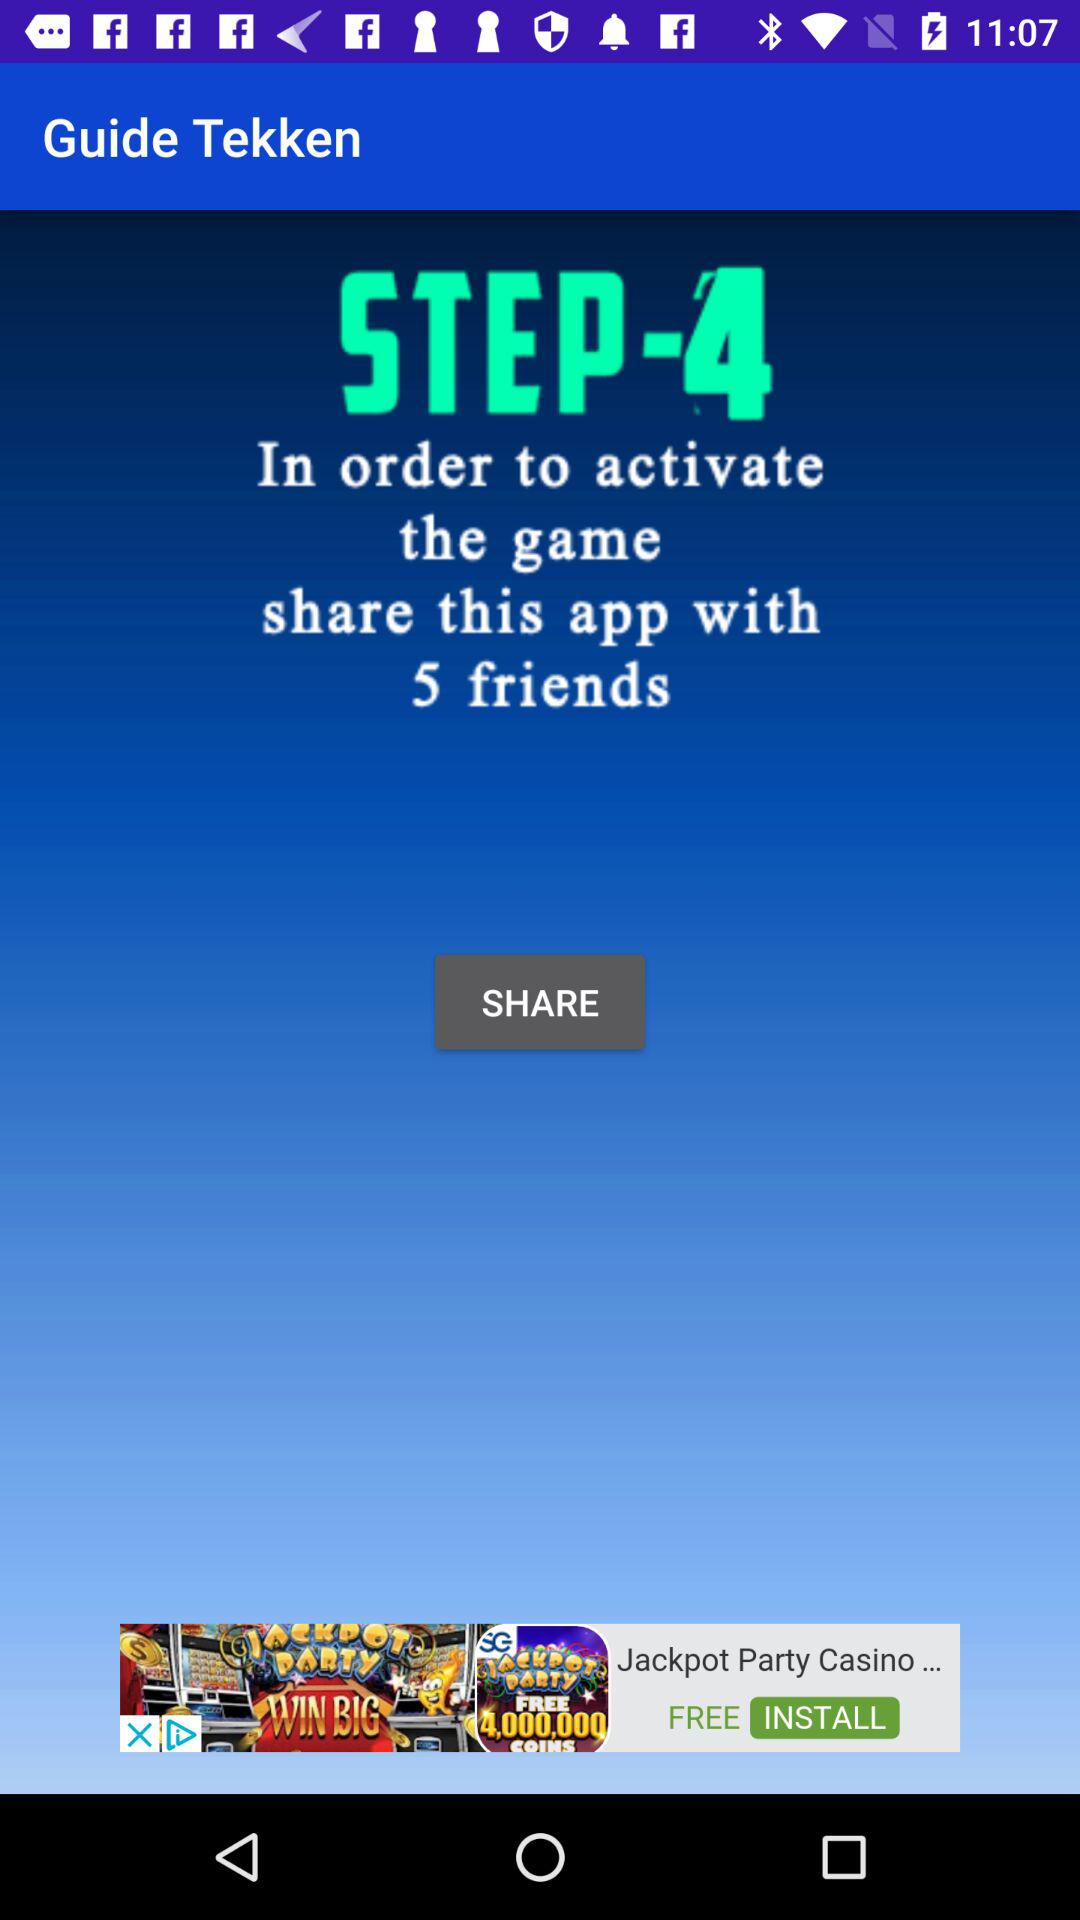What is the application name? The application name is "Guide Tekken". 